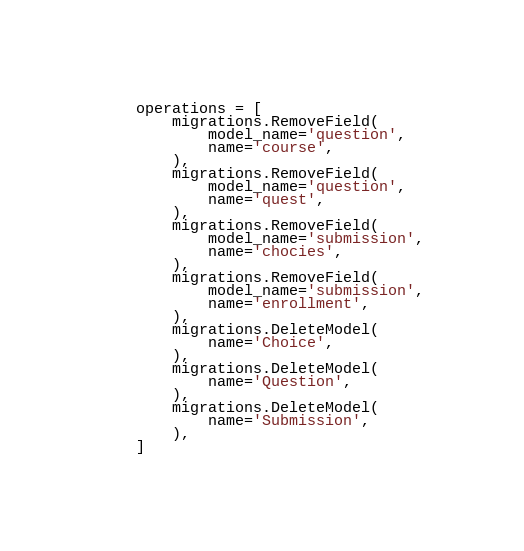Convert code to text. <code><loc_0><loc_0><loc_500><loc_500><_Python_>
    operations = [
        migrations.RemoveField(
            model_name='question',
            name='course',
        ),
        migrations.RemoveField(
            model_name='question',
            name='quest',
        ),
        migrations.RemoveField(
            model_name='submission',
            name='chocies',
        ),
        migrations.RemoveField(
            model_name='submission',
            name='enrollment',
        ),
        migrations.DeleteModel(
            name='Choice',
        ),
        migrations.DeleteModel(
            name='Question',
        ),
        migrations.DeleteModel(
            name='Submission',
        ),
    ]
</code> 